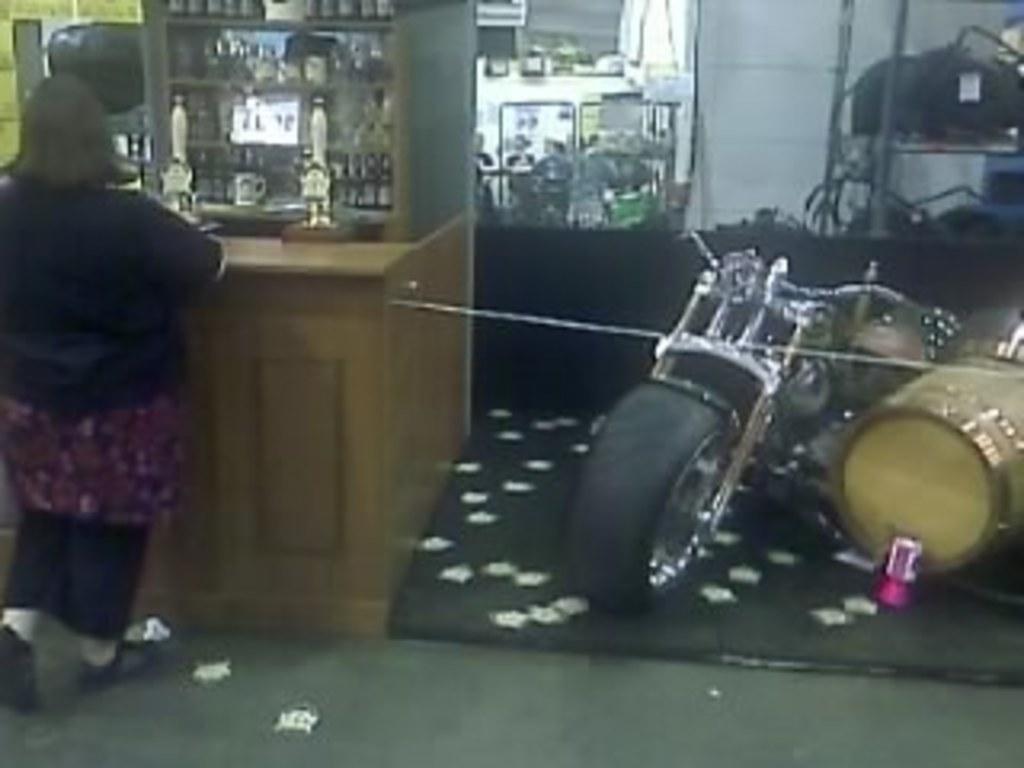How would you summarize this image in a sentence or two? In this picture we can see a woman standing beside to the table and on table we have bottles, racks and in the background we can see bike, drums, wall. 